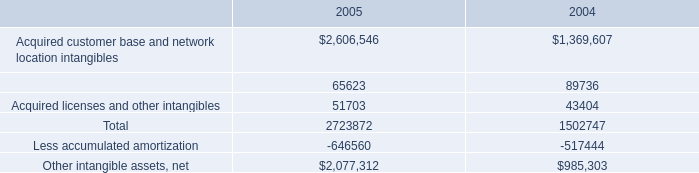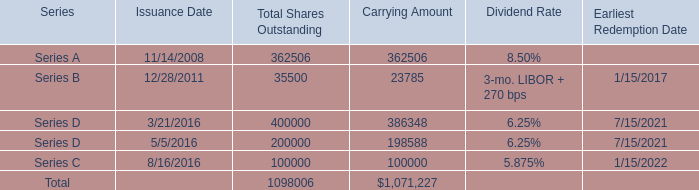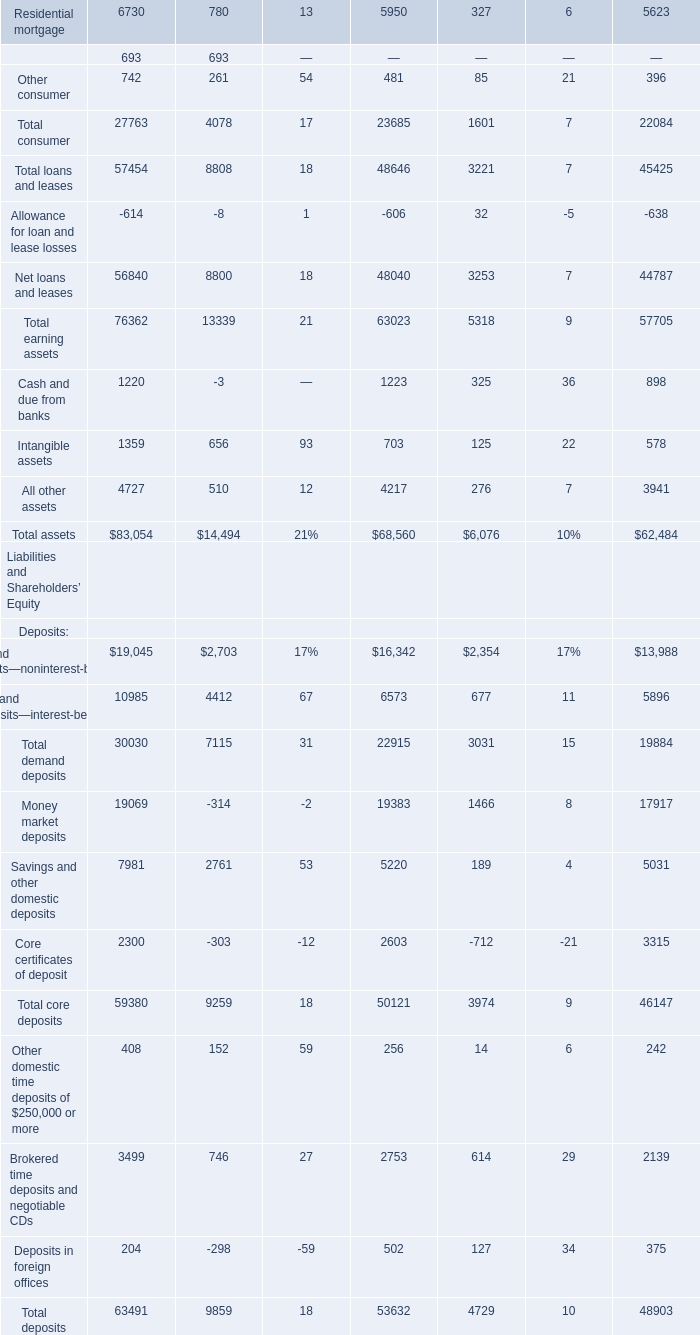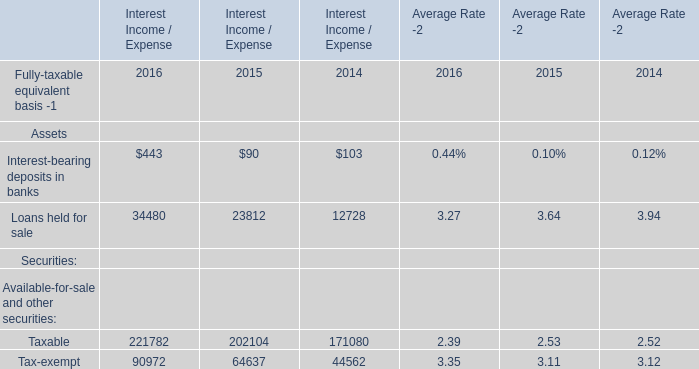What is the sum of Interest-bearing deposits in banks, Loans held for sale and Taxable in 2016 ? 
Computations: ((443 + 34480) + 221782)
Answer: 256705.0. 